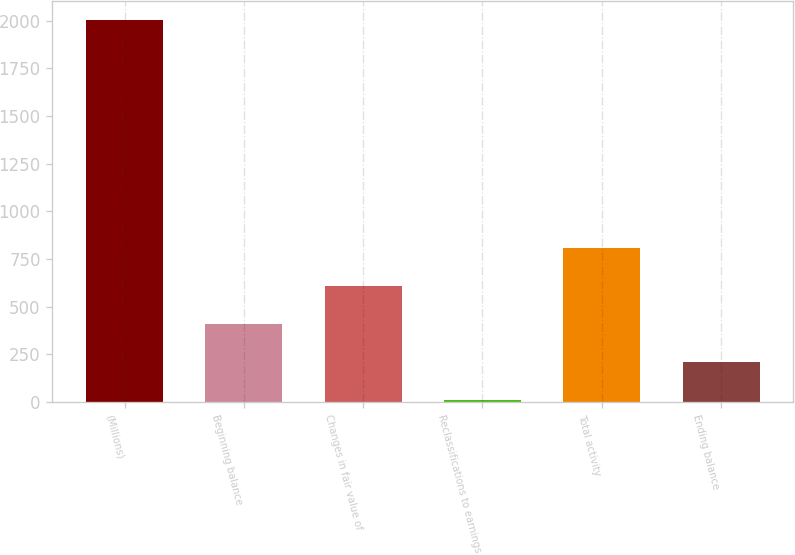Convert chart to OTSL. <chart><loc_0><loc_0><loc_500><loc_500><bar_chart><fcel>(Millions)<fcel>Beginning balance<fcel>Changes in fair value of<fcel>Reclassifications to earnings<fcel>Total activity<fcel>Ending balance<nl><fcel>2005<fcel>409<fcel>608.5<fcel>10<fcel>808<fcel>209.5<nl></chart> 